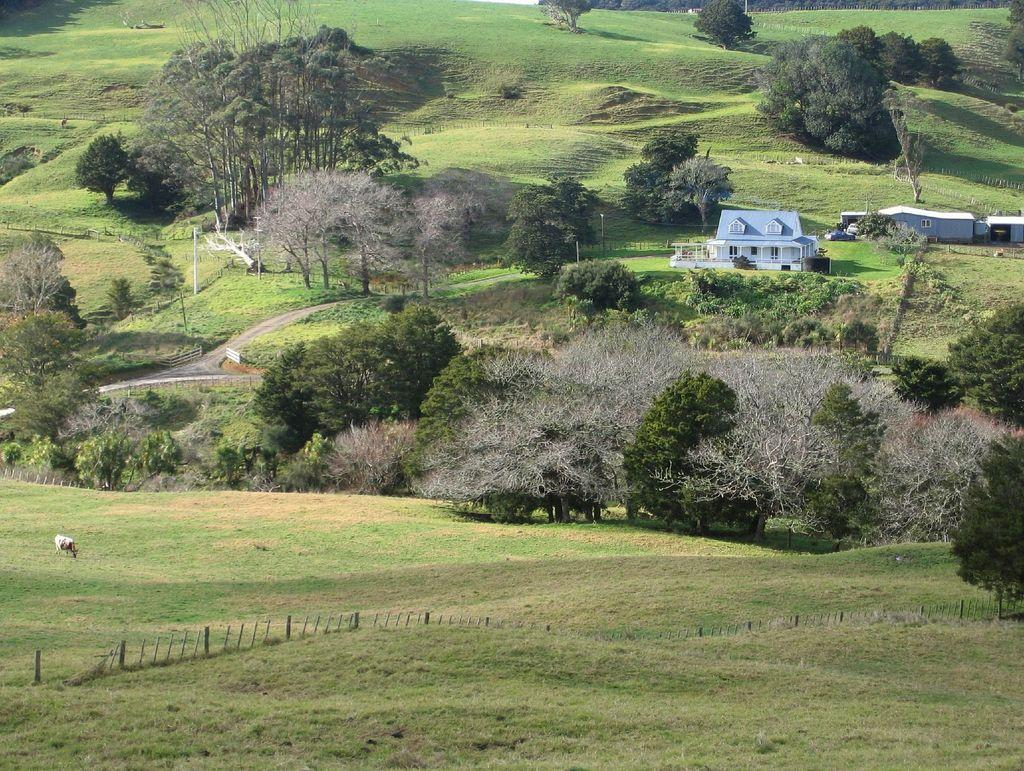What type of vegetation is present in the image? There is grass in the image. What type of structures can be seen in the image? There are houses in the image. What other natural elements are visible in the image? There are trees in the image. What man-made objects can be seen in the image? There are poles and a fence in the image. What type of fruit is hanging from the trees in the image? There is no fruit visible in the image; only trees are present. How many potatoes can be seen in the image? There are no potatoes present in the image. 